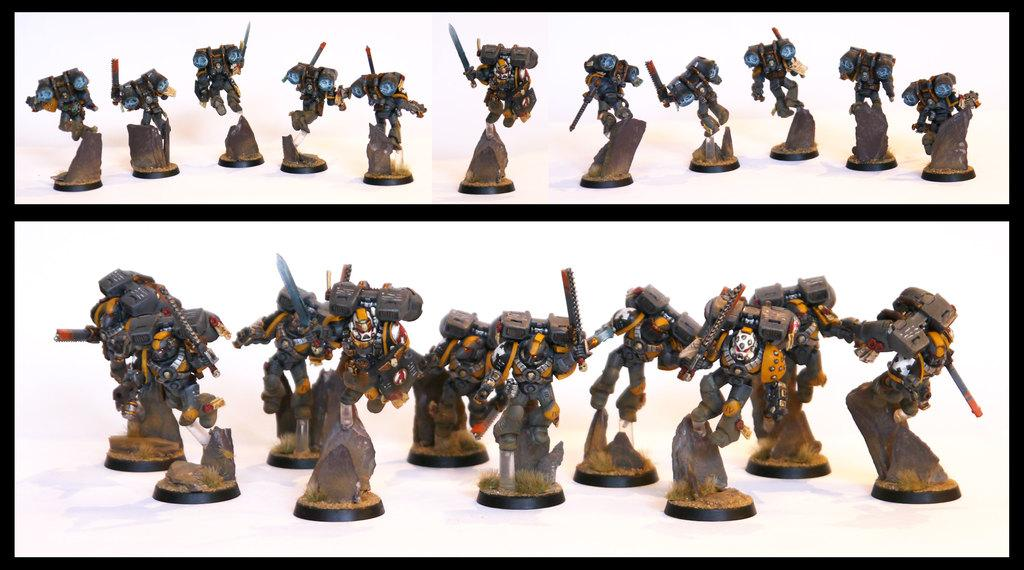What type of objects can be seen in the image? There are toys in the image. Can you describe the appearance of the toys? The toys look like robots. What color are the songs in the image? There are no songs present in the image, so it is not possible to determine their color. 